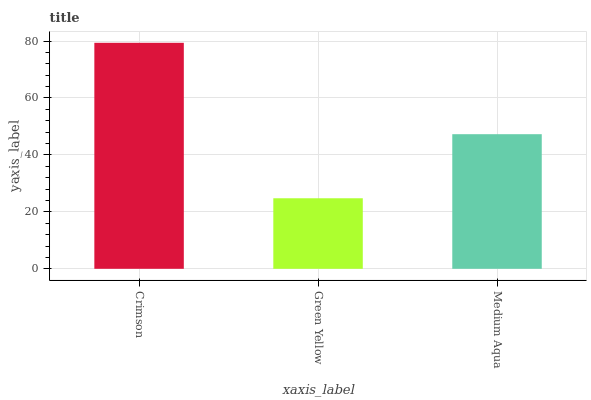Is Green Yellow the minimum?
Answer yes or no. Yes. Is Crimson the maximum?
Answer yes or no. Yes. Is Medium Aqua the minimum?
Answer yes or no. No. Is Medium Aqua the maximum?
Answer yes or no. No. Is Medium Aqua greater than Green Yellow?
Answer yes or no. Yes. Is Green Yellow less than Medium Aqua?
Answer yes or no. Yes. Is Green Yellow greater than Medium Aqua?
Answer yes or no. No. Is Medium Aqua less than Green Yellow?
Answer yes or no. No. Is Medium Aqua the high median?
Answer yes or no. Yes. Is Medium Aqua the low median?
Answer yes or no. Yes. Is Crimson the high median?
Answer yes or no. No. Is Green Yellow the low median?
Answer yes or no. No. 